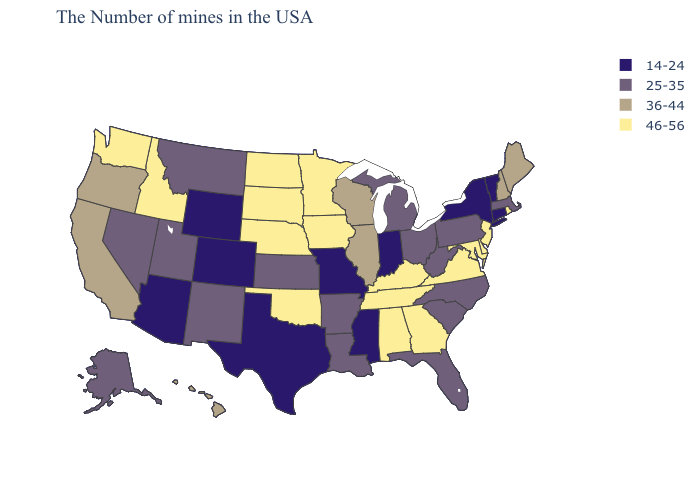What is the value of Illinois?
Keep it brief. 36-44. Name the states that have a value in the range 46-56?
Quick response, please. Rhode Island, New Jersey, Delaware, Maryland, Virginia, Georgia, Kentucky, Alabama, Tennessee, Minnesota, Iowa, Nebraska, Oklahoma, South Dakota, North Dakota, Idaho, Washington. Name the states that have a value in the range 25-35?
Quick response, please. Massachusetts, Pennsylvania, North Carolina, South Carolina, West Virginia, Ohio, Florida, Michigan, Louisiana, Arkansas, Kansas, New Mexico, Utah, Montana, Nevada, Alaska. What is the value of Delaware?
Short answer required. 46-56. What is the lowest value in the MidWest?
Quick response, please. 14-24. Among the states that border Colorado , does Arizona have the lowest value?
Answer briefly. Yes. What is the value of Oregon?
Short answer required. 36-44. Does Colorado have the lowest value in the USA?
Answer briefly. Yes. Name the states that have a value in the range 46-56?
Be succinct. Rhode Island, New Jersey, Delaware, Maryland, Virginia, Georgia, Kentucky, Alabama, Tennessee, Minnesota, Iowa, Nebraska, Oklahoma, South Dakota, North Dakota, Idaho, Washington. Does South Carolina have a lower value than Nevada?
Write a very short answer. No. Name the states that have a value in the range 46-56?
Quick response, please. Rhode Island, New Jersey, Delaware, Maryland, Virginia, Georgia, Kentucky, Alabama, Tennessee, Minnesota, Iowa, Nebraska, Oklahoma, South Dakota, North Dakota, Idaho, Washington. What is the lowest value in the South?
Short answer required. 14-24. 